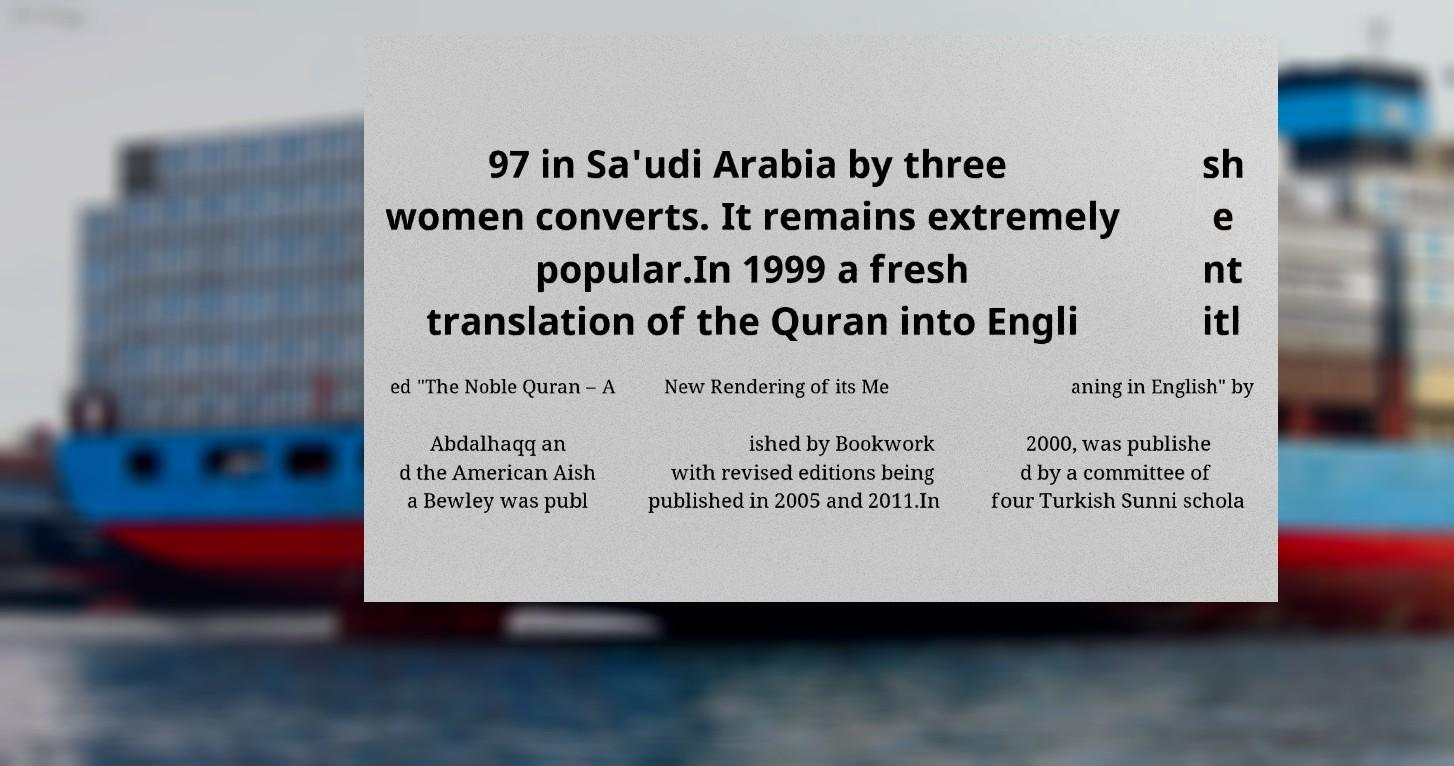I need the written content from this picture converted into text. Can you do that? 97 in Sa'udi Arabia by three women converts. It remains extremely popular.In 1999 a fresh translation of the Quran into Engli sh e nt itl ed "The Noble Quran – A New Rendering of its Me aning in English" by Abdalhaqq an d the American Aish a Bewley was publ ished by Bookwork with revised editions being published in 2005 and 2011.In 2000, was publishe d by a committee of four Turkish Sunni schola 